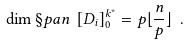<formula> <loc_0><loc_0><loc_500><loc_500>\dim \S p a n \ [ D _ { i } ] _ { 0 } ^ { k ^ { * } } = p \lfloor \frac { n } { p } \rfloor \ .</formula> 